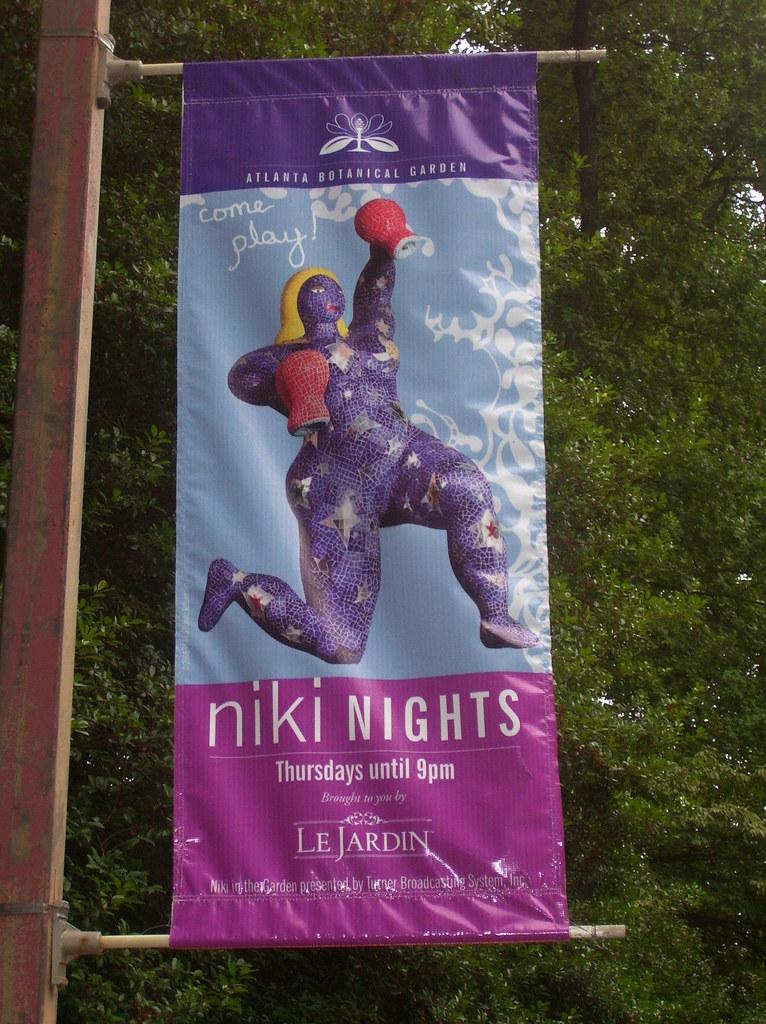What is hanging from the pole in the image? There is a banner in the image that is attached to a pole. Can you describe the banner's positioning? The banner is hanging from the pole. What can be seen in the background of the image? There are leaves visible in the background of the image. How many deer are sitting on the seat in the image? There are no deer or seats present in the image. 